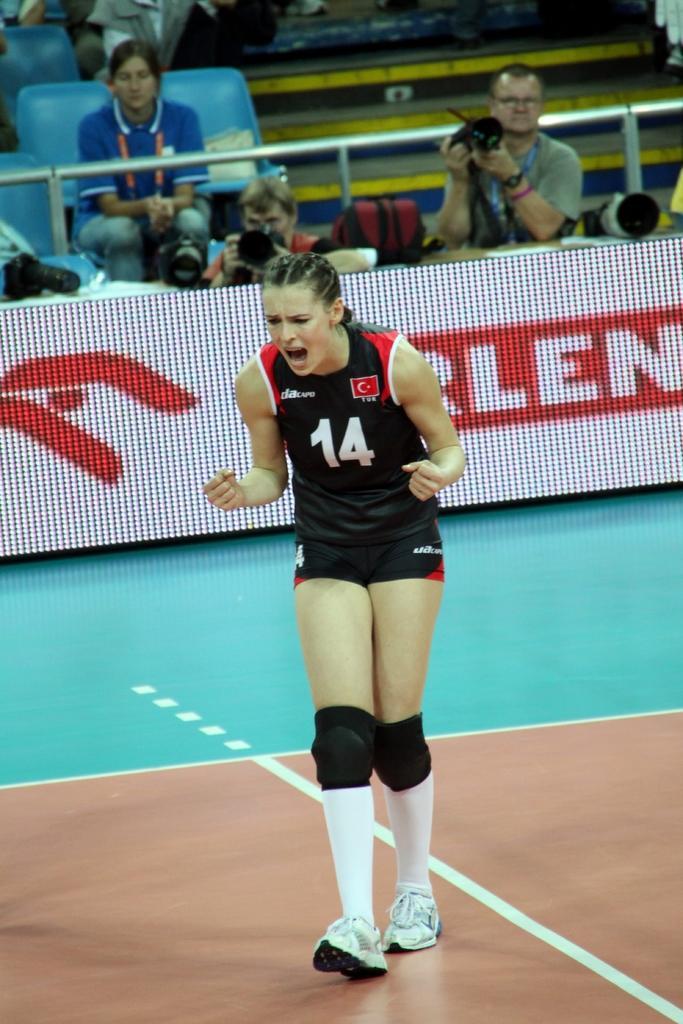Could you give a brief overview of what you see in this image? In the foreground of this image, there is a woman in black dress standing on a tennis court. In the background, there are two persons holding camera in their hands and on top there is a woman, stairs and chairs. 